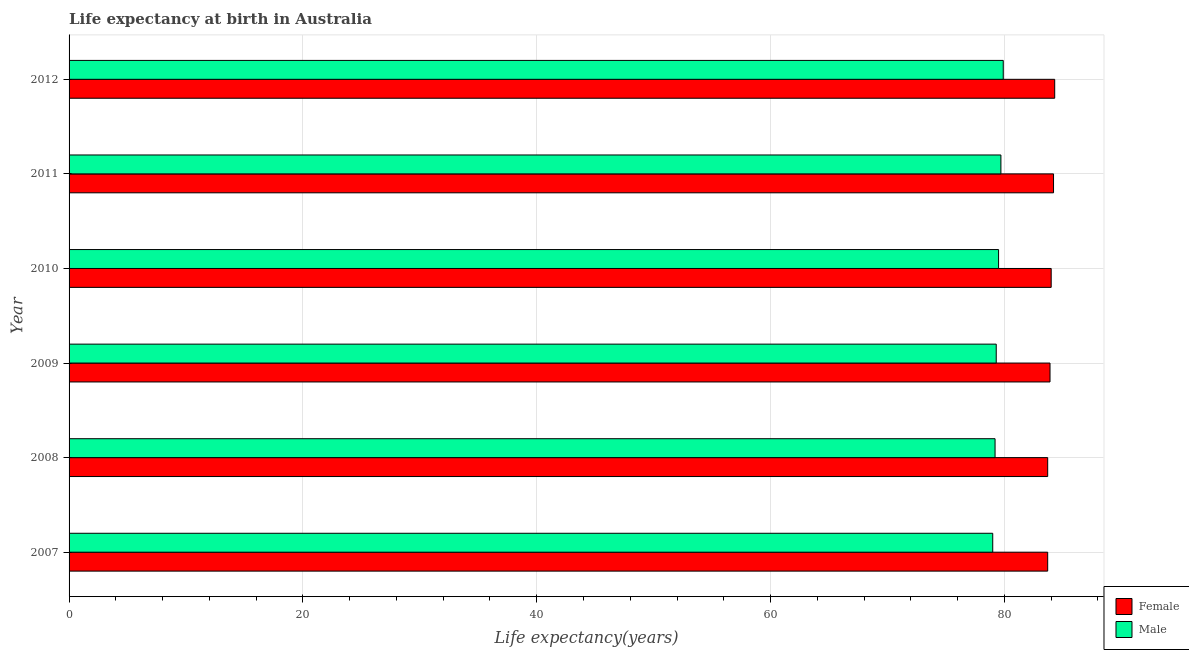How many different coloured bars are there?
Ensure brevity in your answer.  2. Are the number of bars per tick equal to the number of legend labels?
Provide a short and direct response. Yes. What is the label of the 1st group of bars from the top?
Provide a succinct answer. 2012. Across all years, what is the maximum life expectancy(male)?
Ensure brevity in your answer.  79.9. Across all years, what is the minimum life expectancy(female)?
Your answer should be very brief. 83.7. In which year was the life expectancy(female) maximum?
Give a very brief answer. 2012. What is the total life expectancy(female) in the graph?
Your answer should be compact. 503.8. What is the difference between the life expectancy(male) in 2008 and that in 2009?
Offer a terse response. -0.1. What is the difference between the life expectancy(female) in 2008 and the life expectancy(male) in 2010?
Give a very brief answer. 4.2. What is the average life expectancy(female) per year?
Keep it short and to the point. 83.97. What is the ratio of the life expectancy(female) in 2011 to that in 2012?
Make the answer very short. 1. Is the difference between the life expectancy(male) in 2007 and 2012 greater than the difference between the life expectancy(female) in 2007 and 2012?
Your answer should be very brief. No. What is the difference between the highest and the lowest life expectancy(male)?
Make the answer very short. 0.9. In how many years, is the life expectancy(female) greater than the average life expectancy(female) taken over all years?
Offer a very short reply. 3. What does the 2nd bar from the top in 2011 represents?
Ensure brevity in your answer.  Female. Does the graph contain any zero values?
Your answer should be very brief. No. What is the title of the graph?
Provide a short and direct response. Life expectancy at birth in Australia. What is the label or title of the X-axis?
Provide a short and direct response. Life expectancy(years). What is the label or title of the Y-axis?
Give a very brief answer. Year. What is the Life expectancy(years) in Female in 2007?
Ensure brevity in your answer.  83.7. What is the Life expectancy(years) in Male in 2007?
Offer a terse response. 79. What is the Life expectancy(years) in Female in 2008?
Make the answer very short. 83.7. What is the Life expectancy(years) in Male in 2008?
Provide a short and direct response. 79.2. What is the Life expectancy(years) in Female in 2009?
Your answer should be very brief. 83.9. What is the Life expectancy(years) in Male in 2009?
Offer a very short reply. 79.3. What is the Life expectancy(years) of Female in 2010?
Your response must be concise. 84. What is the Life expectancy(years) in Male in 2010?
Provide a succinct answer. 79.5. What is the Life expectancy(years) in Female in 2011?
Your answer should be compact. 84.2. What is the Life expectancy(years) of Male in 2011?
Ensure brevity in your answer.  79.7. What is the Life expectancy(years) in Female in 2012?
Keep it short and to the point. 84.3. What is the Life expectancy(years) of Male in 2012?
Provide a short and direct response. 79.9. Across all years, what is the maximum Life expectancy(years) in Female?
Your response must be concise. 84.3. Across all years, what is the maximum Life expectancy(years) in Male?
Your answer should be very brief. 79.9. Across all years, what is the minimum Life expectancy(years) of Female?
Your answer should be compact. 83.7. Across all years, what is the minimum Life expectancy(years) in Male?
Keep it short and to the point. 79. What is the total Life expectancy(years) in Female in the graph?
Give a very brief answer. 503.8. What is the total Life expectancy(years) of Male in the graph?
Offer a very short reply. 476.6. What is the difference between the Life expectancy(years) of Male in 2007 and that in 2008?
Your response must be concise. -0.2. What is the difference between the Life expectancy(years) in Male in 2007 and that in 2009?
Your answer should be compact. -0.3. What is the difference between the Life expectancy(years) of Male in 2007 and that in 2010?
Offer a very short reply. -0.5. What is the difference between the Life expectancy(years) in Female in 2007 and that in 2011?
Keep it short and to the point. -0.5. What is the difference between the Life expectancy(years) in Female in 2007 and that in 2012?
Keep it short and to the point. -0.6. What is the difference between the Life expectancy(years) in Male in 2007 and that in 2012?
Offer a terse response. -0.9. What is the difference between the Life expectancy(years) of Female in 2008 and that in 2009?
Give a very brief answer. -0.2. What is the difference between the Life expectancy(years) in Male in 2008 and that in 2010?
Keep it short and to the point. -0.3. What is the difference between the Life expectancy(years) of Female in 2008 and that in 2012?
Give a very brief answer. -0.6. What is the difference between the Life expectancy(years) of Male in 2008 and that in 2012?
Provide a succinct answer. -0.7. What is the difference between the Life expectancy(years) of Female in 2009 and that in 2011?
Your answer should be compact. -0.3. What is the difference between the Life expectancy(years) of Female in 2009 and that in 2012?
Provide a short and direct response. -0.4. What is the difference between the Life expectancy(years) of Male in 2009 and that in 2012?
Provide a succinct answer. -0.6. What is the difference between the Life expectancy(years) in Male in 2010 and that in 2011?
Your answer should be compact. -0.2. What is the difference between the Life expectancy(years) of Female in 2010 and that in 2012?
Provide a succinct answer. -0.3. What is the difference between the Life expectancy(years) of Male in 2010 and that in 2012?
Offer a terse response. -0.4. What is the difference between the Life expectancy(years) of Female in 2011 and that in 2012?
Your answer should be compact. -0.1. What is the difference between the Life expectancy(years) in Female in 2007 and the Life expectancy(years) in Male in 2009?
Offer a very short reply. 4.4. What is the difference between the Life expectancy(years) of Female in 2007 and the Life expectancy(years) of Male in 2010?
Offer a very short reply. 4.2. What is the difference between the Life expectancy(years) in Female in 2008 and the Life expectancy(years) in Male in 2009?
Your answer should be compact. 4.4. What is the difference between the Life expectancy(years) of Female in 2008 and the Life expectancy(years) of Male in 2012?
Ensure brevity in your answer.  3.8. What is the difference between the Life expectancy(years) in Female in 2009 and the Life expectancy(years) in Male in 2011?
Your response must be concise. 4.2. What is the difference between the Life expectancy(years) of Female in 2010 and the Life expectancy(years) of Male in 2011?
Provide a succinct answer. 4.3. What is the difference between the Life expectancy(years) of Female in 2010 and the Life expectancy(years) of Male in 2012?
Keep it short and to the point. 4.1. What is the difference between the Life expectancy(years) in Female in 2011 and the Life expectancy(years) in Male in 2012?
Offer a very short reply. 4.3. What is the average Life expectancy(years) in Female per year?
Offer a very short reply. 83.97. What is the average Life expectancy(years) of Male per year?
Offer a terse response. 79.43. In the year 2007, what is the difference between the Life expectancy(years) of Female and Life expectancy(years) of Male?
Ensure brevity in your answer.  4.7. In the year 2008, what is the difference between the Life expectancy(years) in Female and Life expectancy(years) in Male?
Your answer should be very brief. 4.5. In the year 2009, what is the difference between the Life expectancy(years) of Female and Life expectancy(years) of Male?
Your answer should be compact. 4.6. In the year 2010, what is the difference between the Life expectancy(years) in Female and Life expectancy(years) in Male?
Your answer should be compact. 4.5. What is the ratio of the Life expectancy(years) of Female in 2007 to that in 2009?
Offer a terse response. 1. What is the ratio of the Life expectancy(years) of Male in 2007 to that in 2009?
Your response must be concise. 1. What is the ratio of the Life expectancy(years) of Female in 2007 to that in 2010?
Your answer should be compact. 1. What is the ratio of the Life expectancy(years) in Male in 2007 to that in 2010?
Provide a short and direct response. 0.99. What is the ratio of the Life expectancy(years) of Female in 2007 to that in 2011?
Your answer should be very brief. 0.99. What is the ratio of the Life expectancy(years) in Male in 2007 to that in 2011?
Offer a terse response. 0.99. What is the ratio of the Life expectancy(years) of Male in 2007 to that in 2012?
Make the answer very short. 0.99. What is the ratio of the Life expectancy(years) of Female in 2008 to that in 2009?
Your answer should be very brief. 1. What is the ratio of the Life expectancy(years) in Male in 2008 to that in 2010?
Ensure brevity in your answer.  1. What is the ratio of the Life expectancy(years) of Female in 2008 to that in 2012?
Your answer should be very brief. 0.99. What is the ratio of the Life expectancy(years) in Male in 2008 to that in 2012?
Offer a very short reply. 0.99. What is the ratio of the Life expectancy(years) of Female in 2009 to that in 2011?
Your answer should be very brief. 1. What is the ratio of the Life expectancy(years) of Female in 2010 to that in 2011?
Offer a terse response. 1. What is the ratio of the Life expectancy(years) of Male in 2010 to that in 2012?
Offer a very short reply. 0.99. What is the ratio of the Life expectancy(years) in Male in 2011 to that in 2012?
Your answer should be very brief. 1. What is the difference between the highest and the second highest Life expectancy(years) of Female?
Keep it short and to the point. 0.1. What is the difference between the highest and the lowest Life expectancy(years) in Male?
Your answer should be compact. 0.9. 